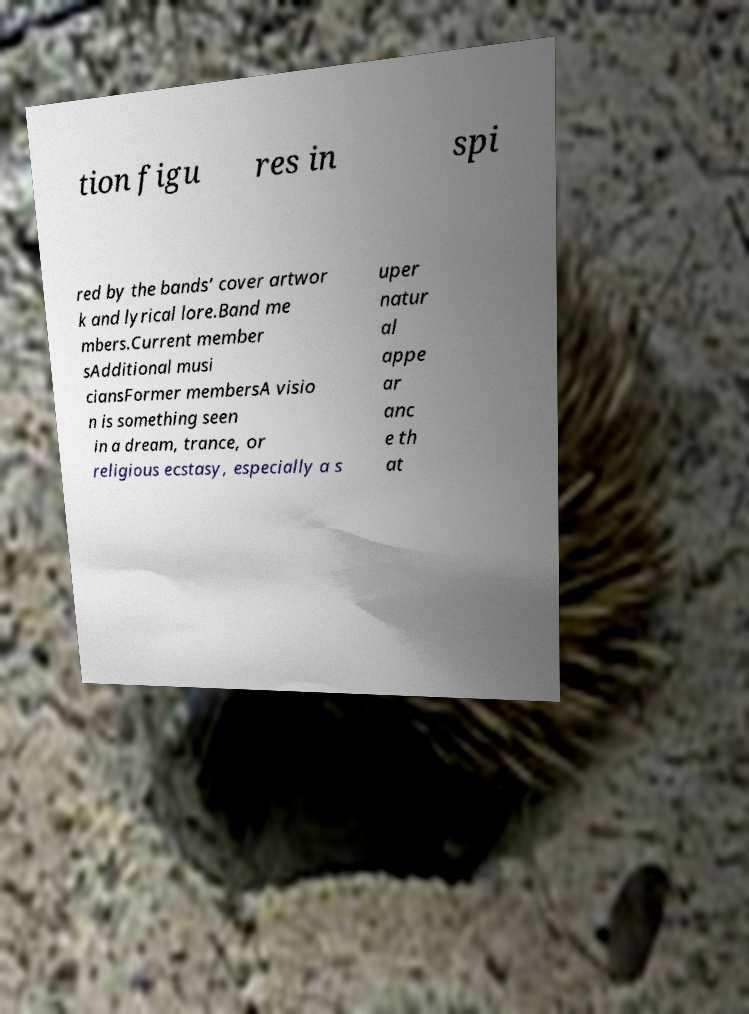What messages or text are displayed in this image? I need them in a readable, typed format. tion figu res in spi red by the bands’ cover artwor k and lyrical lore.Band me mbers.Current member sAdditional musi ciansFormer membersA visio n is something seen in a dream, trance, or religious ecstasy, especially a s uper natur al appe ar anc e th at 